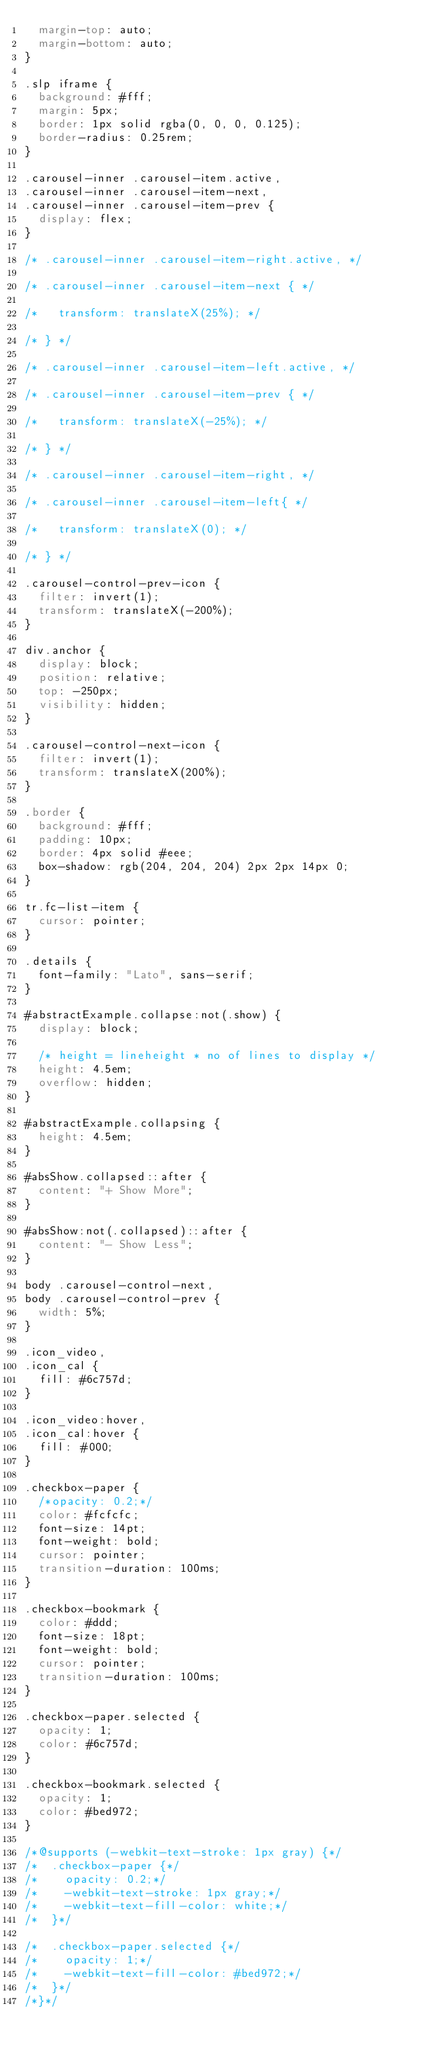<code> <loc_0><loc_0><loc_500><loc_500><_CSS_>  margin-top: auto;
  margin-bottom: auto;
}

.slp iframe {
  background: #fff;
  margin: 5px;
  border: 1px solid rgba(0, 0, 0, 0.125);
  border-radius: 0.25rem;
}

.carousel-inner .carousel-item.active,
.carousel-inner .carousel-item-next,
.carousel-inner .carousel-item-prev {
  display: flex;
}

/* .carousel-inner .carousel-item-right.active, */

/* .carousel-inner .carousel-item-next { */

/*   transform: translateX(25%); */

/* } */

/* .carousel-inner .carousel-item-left.active, */

/* .carousel-inner .carousel-item-prev { */

/*   transform: translateX(-25%); */

/* } */

/* .carousel-inner .carousel-item-right, */

/* .carousel-inner .carousel-item-left{ */

/*   transform: translateX(0); */

/* } */

.carousel-control-prev-icon {
  filter: invert(1);
  transform: translateX(-200%);
}

div.anchor {
  display: block;
  position: relative;
  top: -250px;
  visibility: hidden;
}

.carousel-control-next-icon {
  filter: invert(1);
  transform: translateX(200%);
}

.border {
  background: #fff;
  padding: 10px;
  border: 4px solid #eee;
  box-shadow: rgb(204, 204, 204) 2px 2px 14px 0;
}

tr.fc-list-item {
  cursor: pointer;
}

.details {
  font-family: "Lato", sans-serif;
}

#abstractExample.collapse:not(.show) {
  display: block;

  /* height = lineheight * no of lines to display */
  height: 4.5em;
  overflow: hidden;
}

#abstractExample.collapsing {
  height: 4.5em;
}

#absShow.collapsed::after {
  content: "+ Show More";
}

#absShow:not(.collapsed)::after {
  content: "- Show Less";
}

body .carousel-control-next,
body .carousel-control-prev {
  width: 5%;
}

.icon_video,
.icon_cal {
  fill: #6c757d;
}

.icon_video:hover,
.icon_cal:hover {
  fill: #000;
}

.checkbox-paper {
  /*opacity: 0.2;*/
  color: #fcfcfc;
  font-size: 14pt;
  font-weight: bold;
  cursor: pointer;
  transition-duration: 100ms;
}

.checkbox-bookmark {
  color: #ddd;
  font-size: 18pt;
  font-weight: bold;
  cursor: pointer;
  transition-duration: 100ms;
}

.checkbox-paper.selected {
  opacity: 1;
  color: #6c757d;
}

.checkbox-bookmark.selected {
  opacity: 1;
  color: #bed972;
}

/*@supports (-webkit-text-stroke: 1px gray) {*/
/*  .checkbox-paper {*/
/*    opacity: 0.2;*/
/*    -webkit-text-stroke: 1px gray;*/
/*    -webkit-text-fill-color: white;*/
/*  }*/

/*  .checkbox-paper.selected {*/
/*    opacity: 1;*/
/*    -webkit-text-fill-color: #bed972;*/
/*  }*/
/*}*/
</code> 